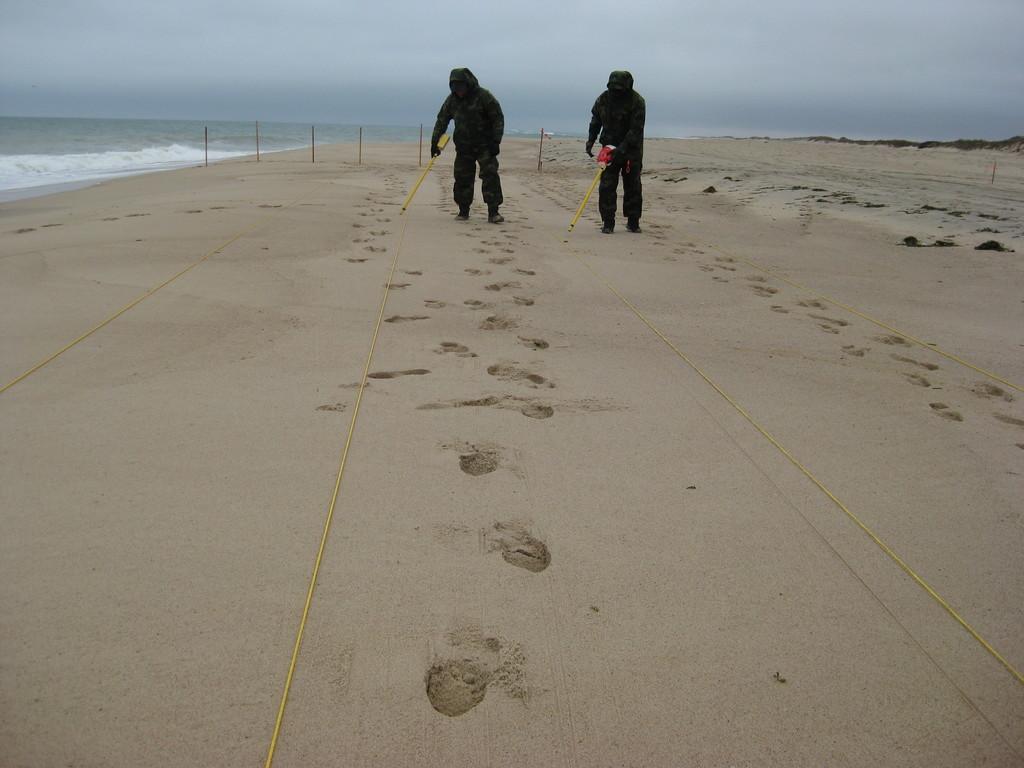In one or two sentences, can you explain what this image depicts? The picture is clicked on the beach. In the foreground there are ropes and sand. In the center of the picture there are two persons walking. In the background there is a water body and sand. The sky is cloudy. 